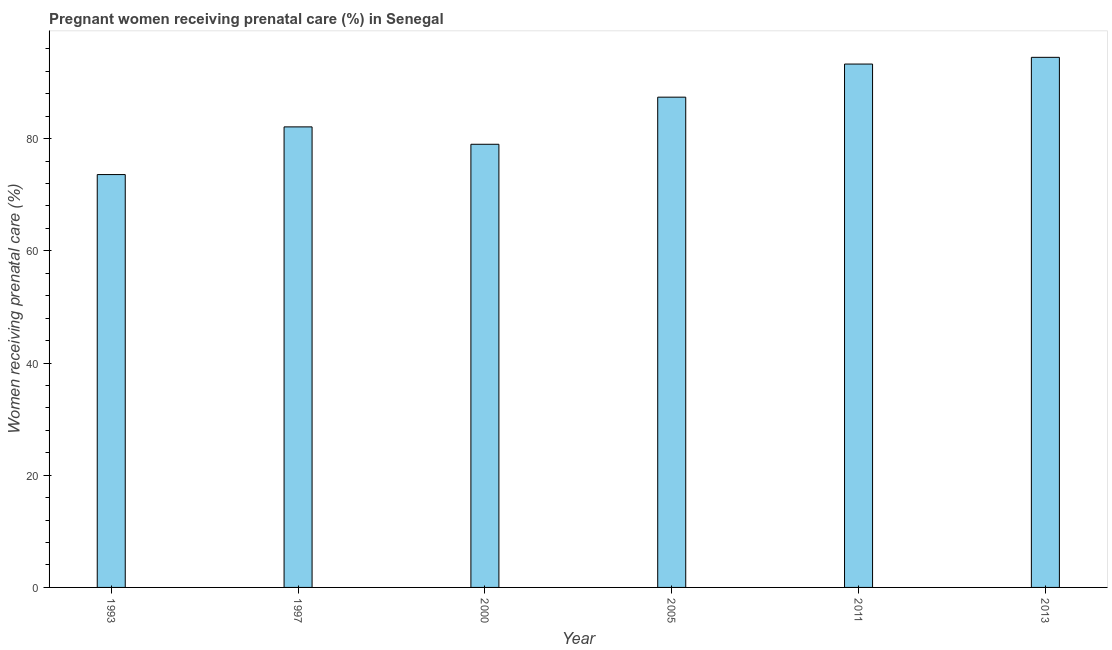Does the graph contain any zero values?
Provide a succinct answer. No. Does the graph contain grids?
Ensure brevity in your answer.  No. What is the title of the graph?
Give a very brief answer. Pregnant women receiving prenatal care (%) in Senegal. What is the label or title of the X-axis?
Offer a very short reply. Year. What is the label or title of the Y-axis?
Your answer should be very brief. Women receiving prenatal care (%). What is the percentage of pregnant women receiving prenatal care in 1997?
Ensure brevity in your answer.  82.1. Across all years, what is the maximum percentage of pregnant women receiving prenatal care?
Your response must be concise. 94.5. Across all years, what is the minimum percentage of pregnant women receiving prenatal care?
Provide a short and direct response. 73.6. In which year was the percentage of pregnant women receiving prenatal care maximum?
Give a very brief answer. 2013. What is the sum of the percentage of pregnant women receiving prenatal care?
Your answer should be compact. 509.9. What is the average percentage of pregnant women receiving prenatal care per year?
Make the answer very short. 84.98. What is the median percentage of pregnant women receiving prenatal care?
Keep it short and to the point. 84.75. Do a majority of the years between 2000 and 1997 (inclusive) have percentage of pregnant women receiving prenatal care greater than 68 %?
Offer a very short reply. No. What is the ratio of the percentage of pregnant women receiving prenatal care in 1997 to that in 2005?
Keep it short and to the point. 0.94. Is the percentage of pregnant women receiving prenatal care in 1993 less than that in 1997?
Your answer should be compact. Yes. What is the difference between the highest and the second highest percentage of pregnant women receiving prenatal care?
Keep it short and to the point. 1.2. Is the sum of the percentage of pregnant women receiving prenatal care in 1997 and 2005 greater than the maximum percentage of pregnant women receiving prenatal care across all years?
Your response must be concise. Yes. What is the difference between the highest and the lowest percentage of pregnant women receiving prenatal care?
Offer a terse response. 20.9. What is the difference between two consecutive major ticks on the Y-axis?
Ensure brevity in your answer.  20. What is the Women receiving prenatal care (%) in 1993?
Your answer should be compact. 73.6. What is the Women receiving prenatal care (%) in 1997?
Your response must be concise. 82.1. What is the Women receiving prenatal care (%) of 2000?
Offer a very short reply. 79. What is the Women receiving prenatal care (%) in 2005?
Your response must be concise. 87.4. What is the Women receiving prenatal care (%) in 2011?
Keep it short and to the point. 93.3. What is the Women receiving prenatal care (%) in 2013?
Give a very brief answer. 94.5. What is the difference between the Women receiving prenatal care (%) in 1993 and 2011?
Provide a succinct answer. -19.7. What is the difference between the Women receiving prenatal care (%) in 1993 and 2013?
Give a very brief answer. -20.9. What is the difference between the Women receiving prenatal care (%) in 1997 and 2011?
Provide a succinct answer. -11.2. What is the difference between the Women receiving prenatal care (%) in 1997 and 2013?
Provide a succinct answer. -12.4. What is the difference between the Women receiving prenatal care (%) in 2000 and 2005?
Provide a short and direct response. -8.4. What is the difference between the Women receiving prenatal care (%) in 2000 and 2011?
Ensure brevity in your answer.  -14.3. What is the difference between the Women receiving prenatal care (%) in 2000 and 2013?
Ensure brevity in your answer.  -15.5. What is the difference between the Women receiving prenatal care (%) in 2005 and 2011?
Ensure brevity in your answer.  -5.9. What is the difference between the Women receiving prenatal care (%) in 2005 and 2013?
Give a very brief answer. -7.1. What is the difference between the Women receiving prenatal care (%) in 2011 and 2013?
Provide a short and direct response. -1.2. What is the ratio of the Women receiving prenatal care (%) in 1993 to that in 1997?
Make the answer very short. 0.9. What is the ratio of the Women receiving prenatal care (%) in 1993 to that in 2000?
Offer a very short reply. 0.93. What is the ratio of the Women receiving prenatal care (%) in 1993 to that in 2005?
Provide a short and direct response. 0.84. What is the ratio of the Women receiving prenatal care (%) in 1993 to that in 2011?
Offer a very short reply. 0.79. What is the ratio of the Women receiving prenatal care (%) in 1993 to that in 2013?
Provide a short and direct response. 0.78. What is the ratio of the Women receiving prenatal care (%) in 1997 to that in 2000?
Offer a very short reply. 1.04. What is the ratio of the Women receiving prenatal care (%) in 1997 to that in 2005?
Your response must be concise. 0.94. What is the ratio of the Women receiving prenatal care (%) in 1997 to that in 2013?
Provide a succinct answer. 0.87. What is the ratio of the Women receiving prenatal care (%) in 2000 to that in 2005?
Your answer should be very brief. 0.9. What is the ratio of the Women receiving prenatal care (%) in 2000 to that in 2011?
Your answer should be very brief. 0.85. What is the ratio of the Women receiving prenatal care (%) in 2000 to that in 2013?
Your response must be concise. 0.84. What is the ratio of the Women receiving prenatal care (%) in 2005 to that in 2011?
Make the answer very short. 0.94. What is the ratio of the Women receiving prenatal care (%) in 2005 to that in 2013?
Provide a short and direct response. 0.93. 